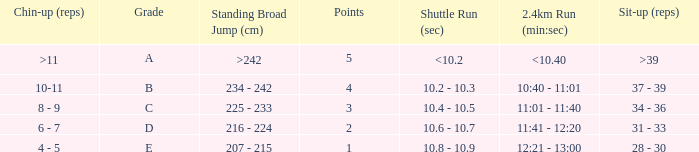Tell me the shuttle run with grade c 10.4 - 10.5. 